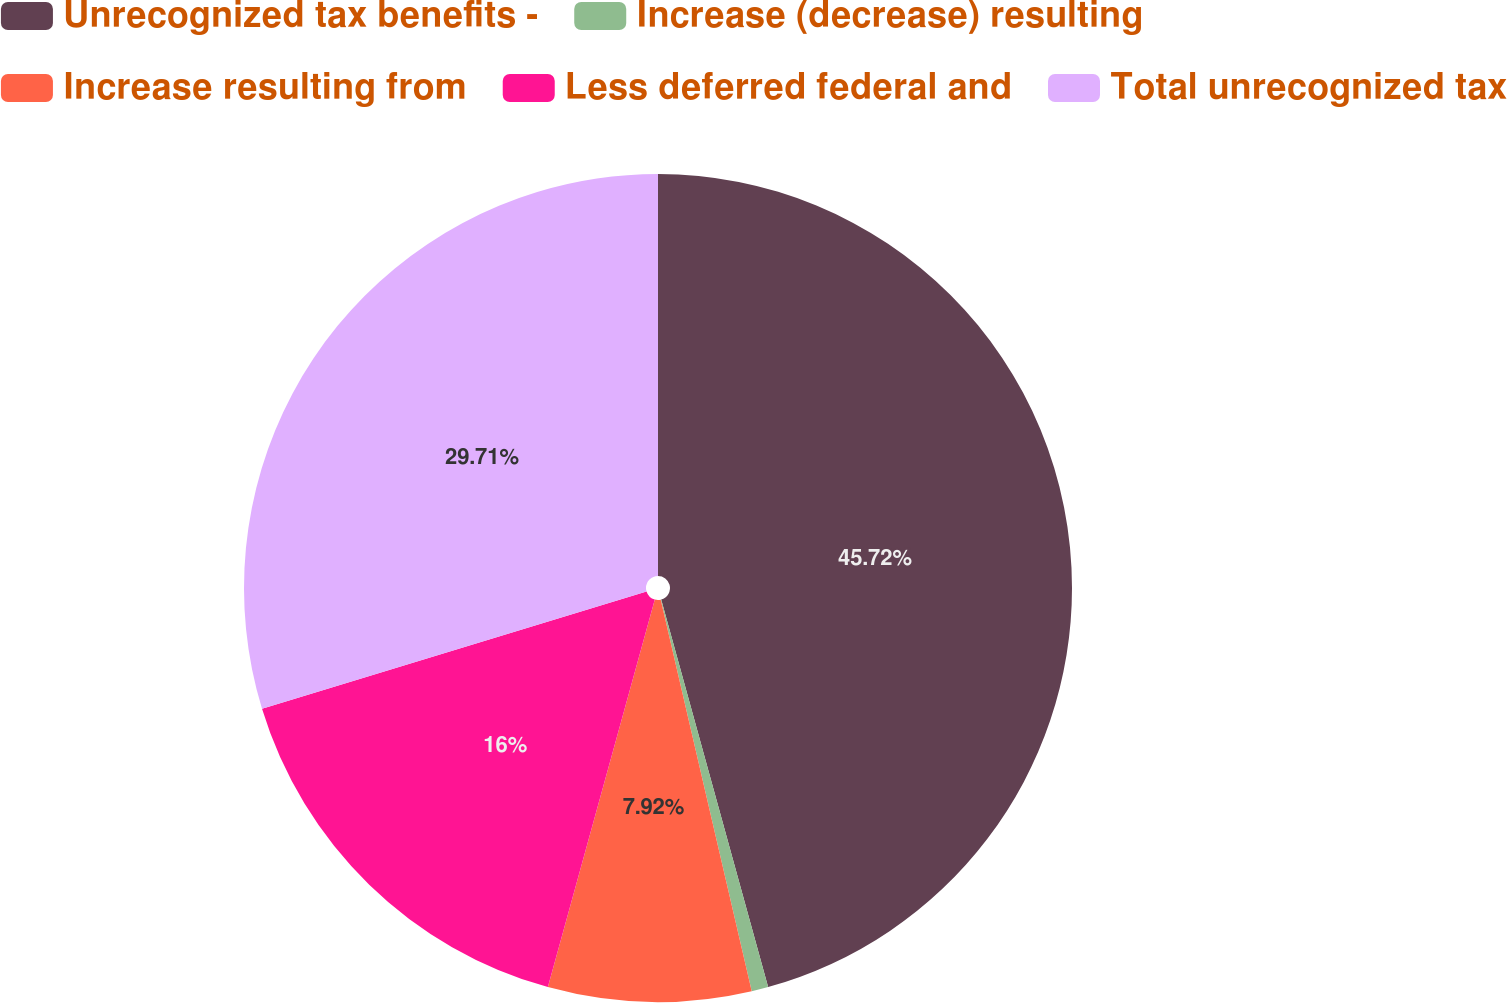Convert chart to OTSL. <chart><loc_0><loc_0><loc_500><loc_500><pie_chart><fcel>Unrecognized tax benefits -<fcel>Increase (decrease) resulting<fcel>Increase resulting from<fcel>Less deferred federal and<fcel>Total unrecognized tax<nl><fcel>45.71%<fcel>0.65%<fcel>7.92%<fcel>16.0%<fcel>29.71%<nl></chart> 